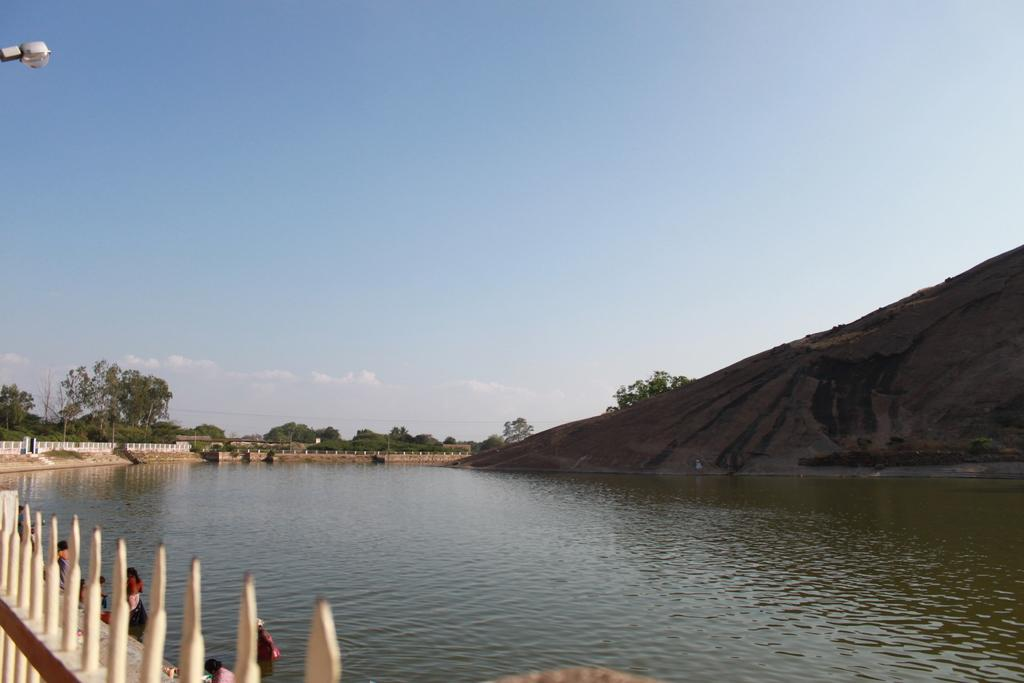What type of barrier can be seen in the image? There is a fence in the image. Who or what is present in the image? There are people in the image. What natural element is visible in the image? There is water visible in the image. What type of geological feature is present in the image? There is a rock in the image. What can be seen in the background of the image? There are trees and the sky visible in the background of the image. Where is the light source coming from in the image? There is a light source visible in the top left side of the image. Can you tell me how many snakes are slithering around the rock in the image? There are no snakes present in the image; it features a fence, people, water, a rock, trees, the sky, and a light source. What type of architectural structure is present behind the trees in the image? There is no specific architectural structure mentioned behind the trees in the image; only trees and the sky are visible in the background. 